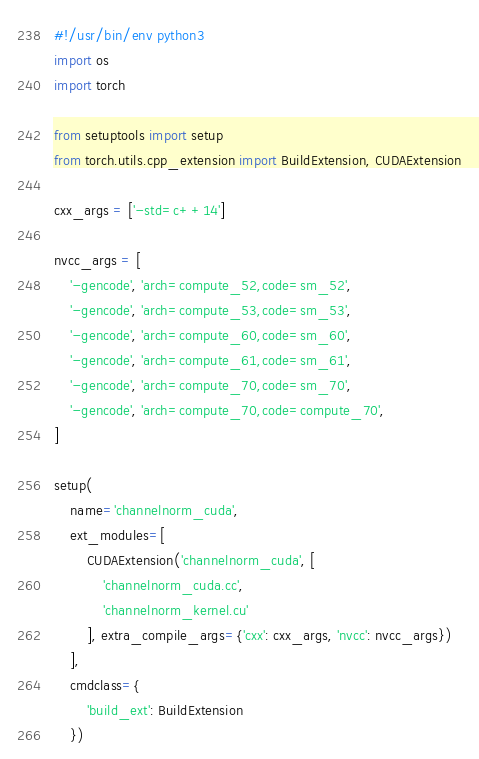Convert code to text. <code><loc_0><loc_0><loc_500><loc_500><_Python_>#!/usr/bin/env python3
import os
import torch

from setuptools import setup
from torch.utils.cpp_extension import BuildExtension, CUDAExtension

cxx_args = ['-std=c++14']

nvcc_args = [
    '-gencode', 'arch=compute_52,code=sm_52',
    '-gencode', 'arch=compute_53,code=sm_53',
    '-gencode', 'arch=compute_60,code=sm_60',
    '-gencode', 'arch=compute_61,code=sm_61',
    '-gencode', 'arch=compute_70,code=sm_70',
    '-gencode', 'arch=compute_70,code=compute_70',
]

setup(
    name='channelnorm_cuda',
    ext_modules=[
        CUDAExtension('channelnorm_cuda', [
            'channelnorm_cuda.cc',
            'channelnorm_kernel.cu'
        ], extra_compile_args={'cxx': cxx_args, 'nvcc': nvcc_args})
    ],
    cmdclass={
        'build_ext': BuildExtension
    })
</code> 